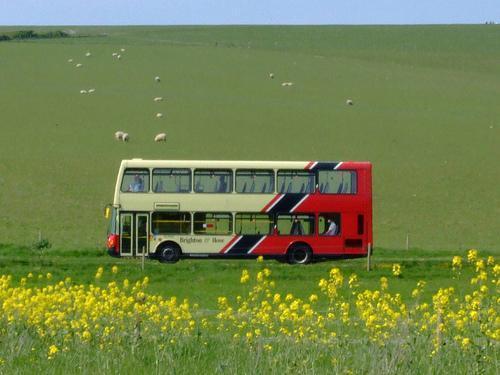How many bus are seen?
Give a very brief answer. 1. 